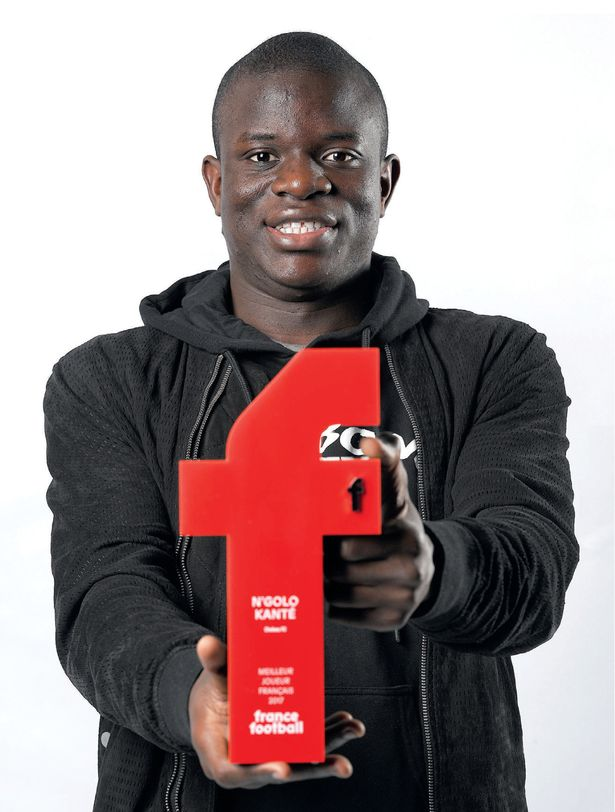What could be some of the challenges faced by the recipient of this award in maintaining their performance in subsequent seasons? Some challenges might include the pressure to maintain a consistent high level of performance and the expectations from fans, coaches, and peers. There can be physical challenges such as injuries or fatigue, given the demanding nature of professional soccer. Additionally, opponents may target him more aggressively, presenting tougher competition. Navigating these factors while balancing personal and professional life can be challenging but crucial for maintaining his status as a top player. 